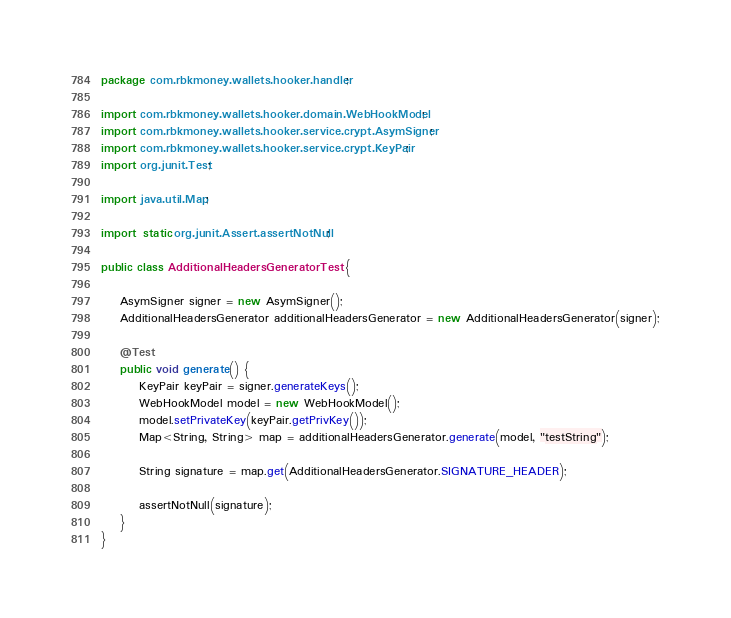Convert code to text. <code><loc_0><loc_0><loc_500><loc_500><_Java_>package com.rbkmoney.wallets.hooker.handler;

import com.rbkmoney.wallets.hooker.domain.WebHookModel;
import com.rbkmoney.wallets.hooker.service.crypt.AsymSigner;
import com.rbkmoney.wallets.hooker.service.crypt.KeyPair;
import org.junit.Test;

import java.util.Map;

import static org.junit.Assert.assertNotNull;

public class AdditionalHeadersGeneratorTest {

    AsymSigner signer = new AsymSigner();
    AdditionalHeadersGenerator additionalHeadersGenerator = new AdditionalHeadersGenerator(signer);

    @Test
    public void generate() {
        KeyPair keyPair = signer.generateKeys();
        WebHookModel model = new WebHookModel();
        model.setPrivateKey(keyPair.getPrivKey());
        Map<String, String> map = additionalHeadersGenerator.generate(model, "testString");

        String signature = map.get(AdditionalHeadersGenerator.SIGNATURE_HEADER);

        assertNotNull(signature);
    }
}</code> 